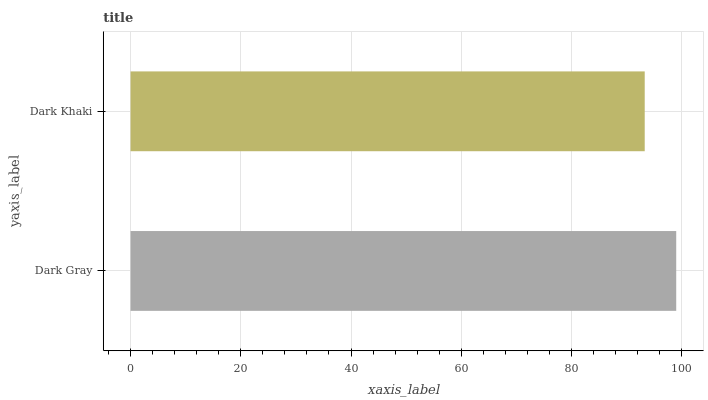Is Dark Khaki the minimum?
Answer yes or no. Yes. Is Dark Gray the maximum?
Answer yes or no. Yes. Is Dark Khaki the maximum?
Answer yes or no. No. Is Dark Gray greater than Dark Khaki?
Answer yes or no. Yes. Is Dark Khaki less than Dark Gray?
Answer yes or no. Yes. Is Dark Khaki greater than Dark Gray?
Answer yes or no. No. Is Dark Gray less than Dark Khaki?
Answer yes or no. No. Is Dark Gray the high median?
Answer yes or no. Yes. Is Dark Khaki the low median?
Answer yes or no. Yes. Is Dark Khaki the high median?
Answer yes or no. No. Is Dark Gray the low median?
Answer yes or no. No. 